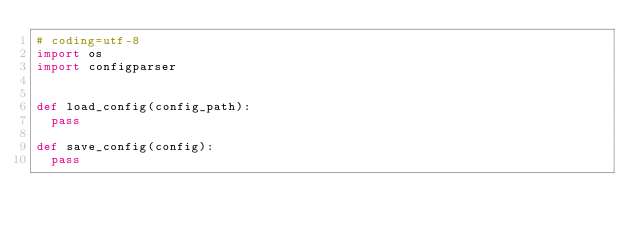<code> <loc_0><loc_0><loc_500><loc_500><_Python_># coding=utf-8
import os
import configparser


def load_config(config_path):
	pass

def save_config(config):
	pass
</code> 